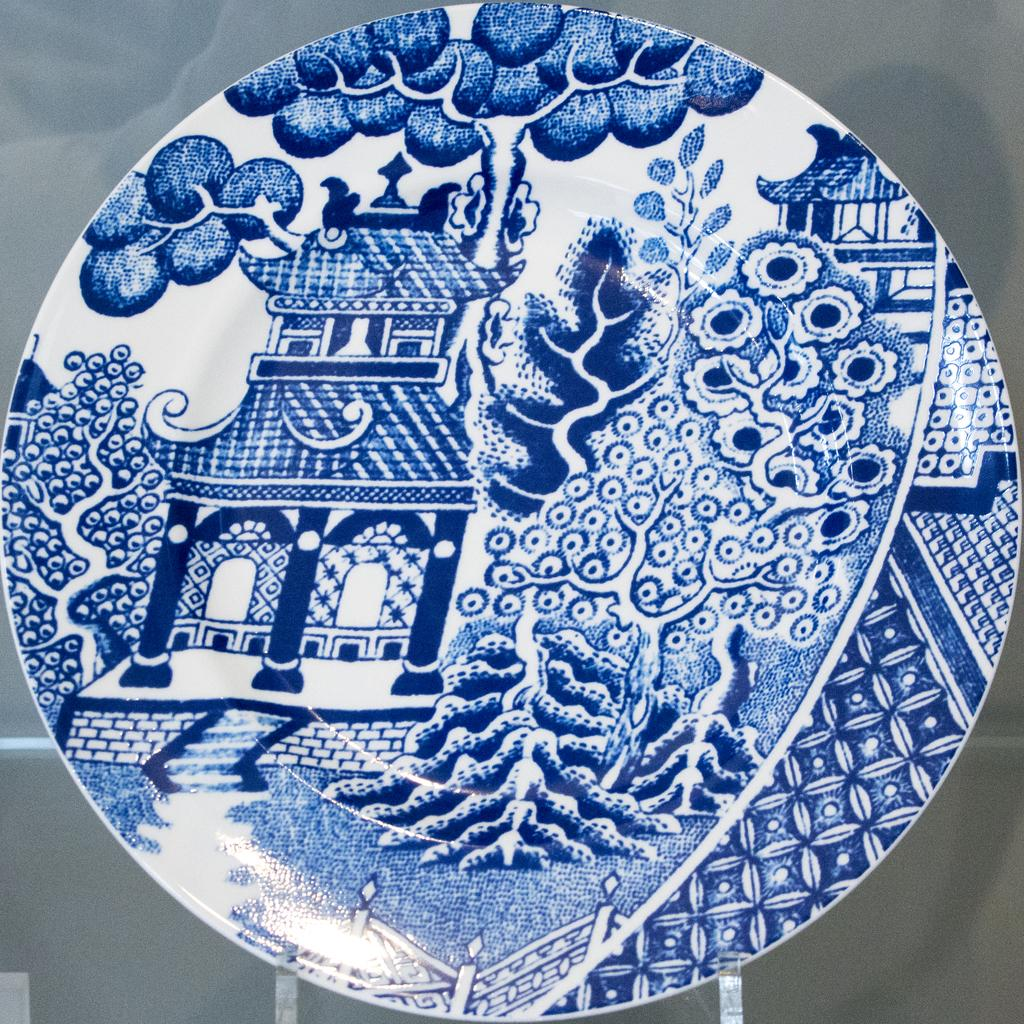What type of plate is visible in the image? There is a white ceramic plate in the image. What color is the design on the plate? The plate has a blue design on it. What type of waste is visible on the plate in the image? There is no waste visible on the plate in the image; it is a white ceramic plate with a blue design. Can you see any feet on the plate in the image? There are no feet visible on the plate in the image; it is a white ceramic plate with a blue design. 